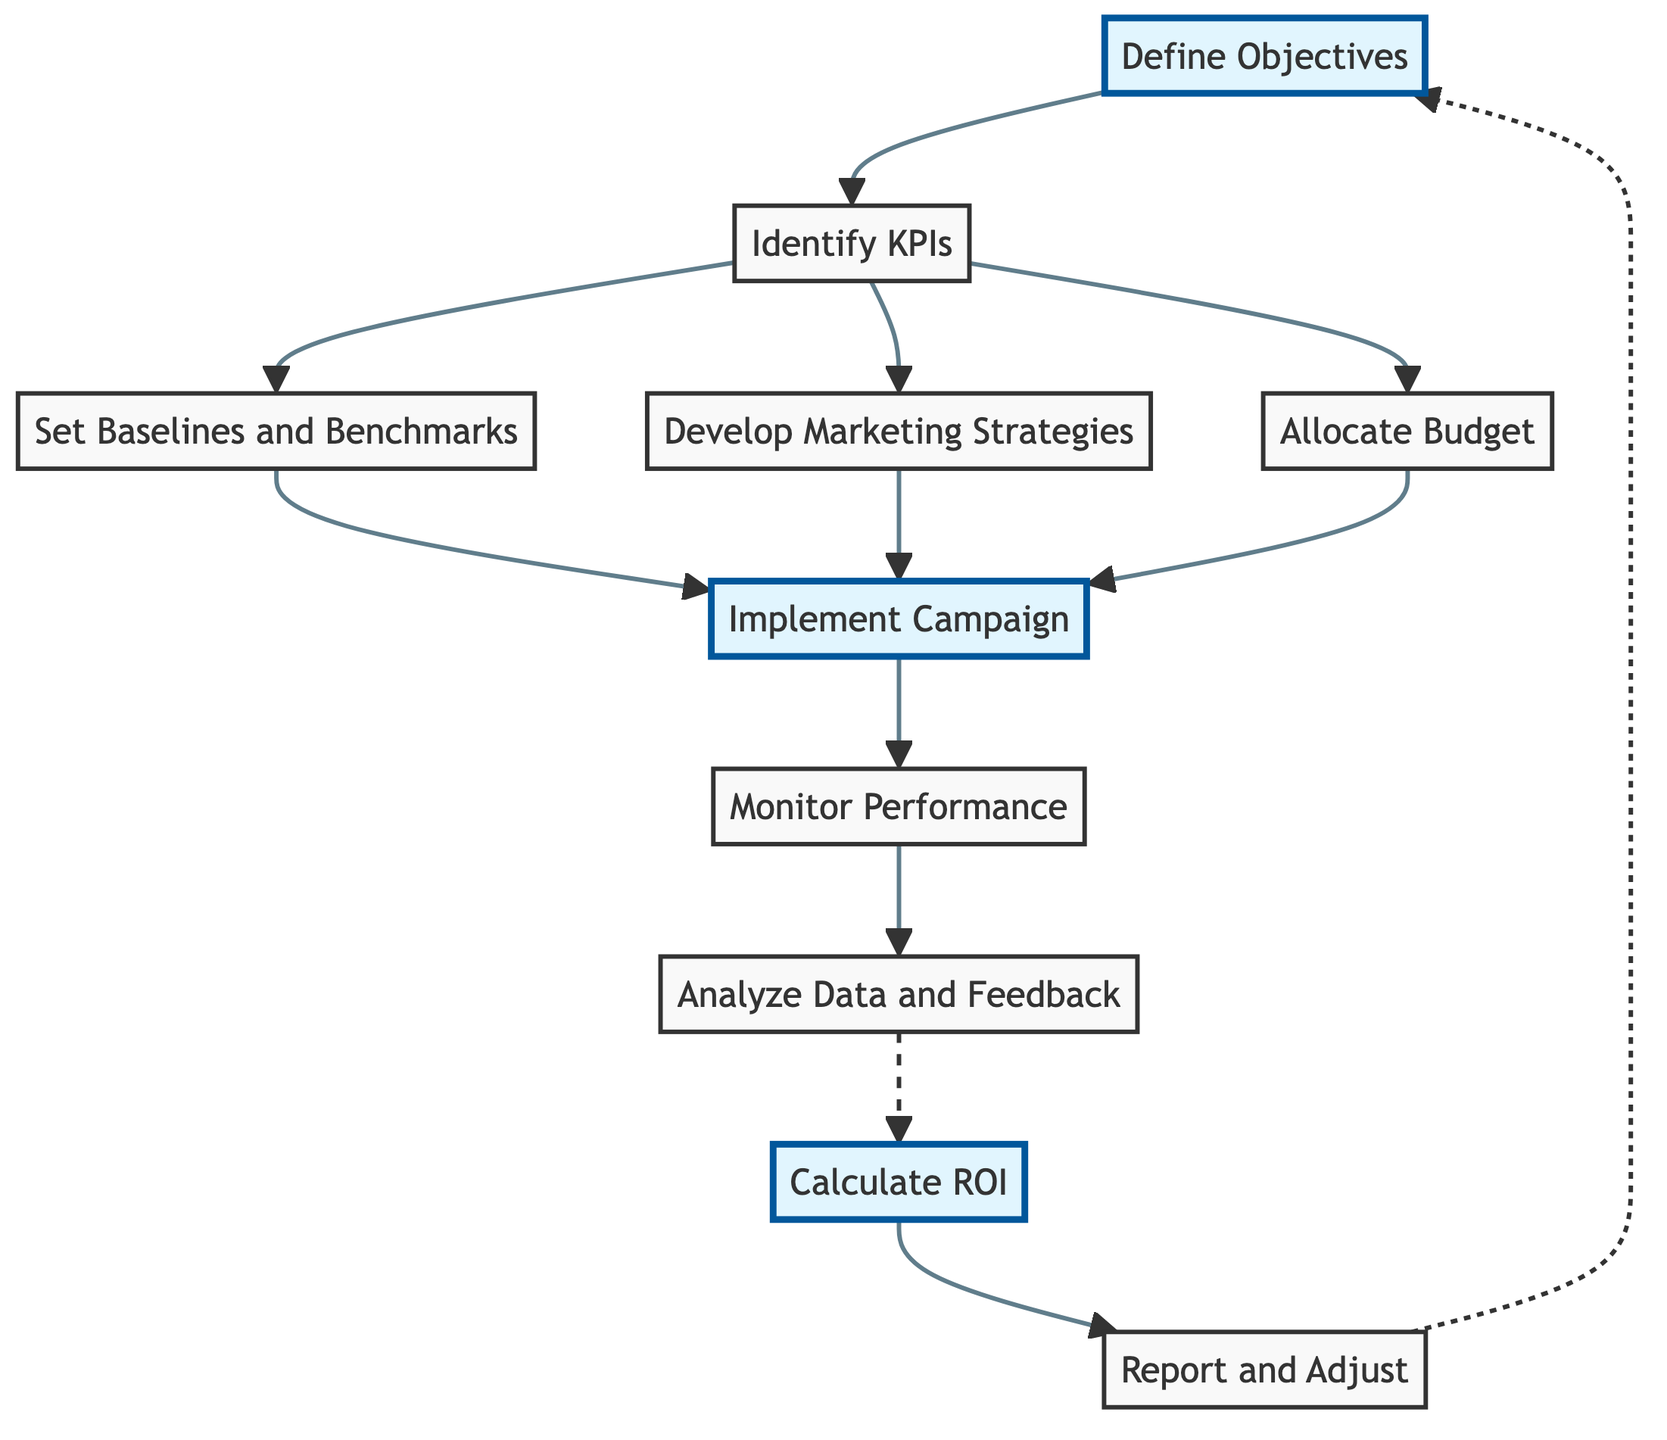What is the first step in the diagram? The diagram starts with "Define Objectives," which is the initial step in the process of evaluating ROI for digital marketing campaigns.
Answer: Define Objectives How many main actions follow after identifying KPIs? After identifying KPIs, there are three main actions listed: "Set Baselines and Benchmarks," "Develop Marketing Strategies," and "Allocate Budget."
Answer: Three What node directly leads to "Implement Campaign"? The nodes that directly lead to "Implement Campaign" are "Set Baselines and Benchmarks," "Develop Marketing Strategies," and "Allocate Budget."
Answer: Set Baselines and Benchmarks, Develop Marketing Strategies, Allocate Budget What is the final step in the process? The last step outlined in the diagram is "Report and Adjust," which wraps up the cycle of evaluating the return on investment.
Answer: Report and Adjust How many total steps are represented in the diagram? The diagram has ten unique steps listed, showing the flow of evaluating digital marketing ROI from start to finish.
Answer: Ten What is the output of the "Calculate ROI" node? The "Calculate ROI" node reflects the action of comparing the revenue generated from campaigns to the total costs to determine return on investment.
Answer: Compare revenue to total costs What happens after "Monitor Performance"? After "Monitor Performance," the next step is "Analyze Data and Feedback," showing that performance tracking leads to data interpretation.
Answer: Analyze Data and Feedback Which node is connected to "Report and Adjust"? "Report and Adjust" is connected to "Calculate ROI," indicating that reporting on performance and ROI follows the calculation step.
Answer: Calculate ROI Which node is highlighted in the diagram? The highlighted nodes in the diagram indicate key stages in the process that are particularly emphasized: "Define Objectives," "Implement Campaign," and "Calculate ROI."
Answer: Define Objectives, Implement Campaign, Calculate ROI 